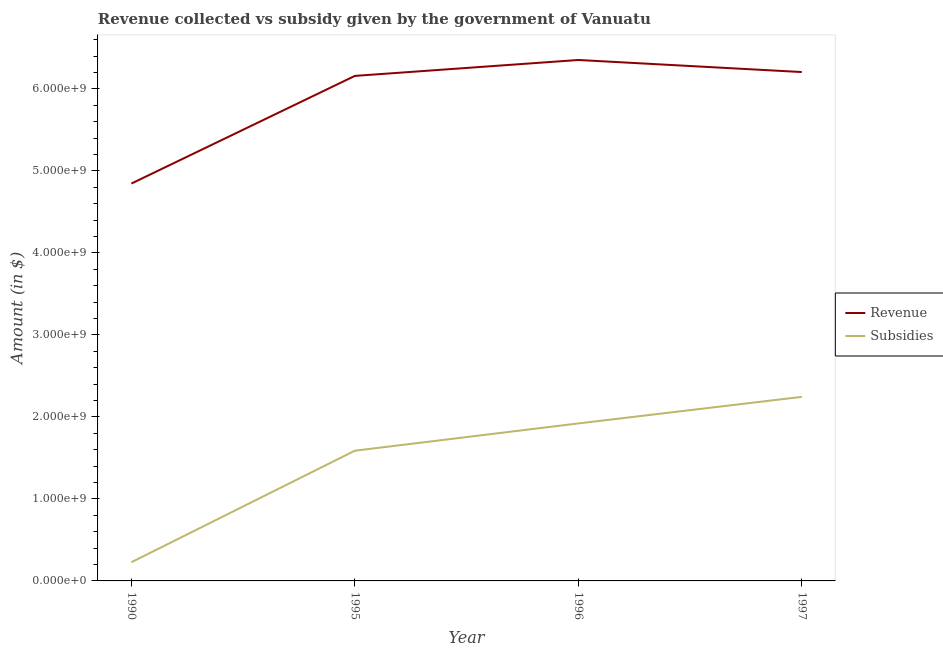Does the line corresponding to amount of subsidies given intersect with the line corresponding to amount of revenue collected?
Ensure brevity in your answer.  No. What is the amount of subsidies given in 1996?
Provide a succinct answer. 1.92e+09. Across all years, what is the maximum amount of subsidies given?
Make the answer very short. 2.24e+09. Across all years, what is the minimum amount of revenue collected?
Give a very brief answer. 4.85e+09. In which year was the amount of subsidies given minimum?
Provide a succinct answer. 1990. What is the total amount of subsidies given in the graph?
Your response must be concise. 5.98e+09. What is the difference between the amount of subsidies given in 1995 and that in 1996?
Offer a terse response. -3.33e+08. What is the difference between the amount of subsidies given in 1995 and the amount of revenue collected in 1990?
Provide a succinct answer. -3.26e+09. What is the average amount of subsidies given per year?
Give a very brief answer. 1.50e+09. In the year 1990, what is the difference between the amount of revenue collected and amount of subsidies given?
Give a very brief answer. 4.62e+09. What is the ratio of the amount of subsidies given in 1990 to that in 1997?
Keep it short and to the point. 0.1. What is the difference between the highest and the second highest amount of revenue collected?
Offer a terse response. 1.47e+08. What is the difference between the highest and the lowest amount of revenue collected?
Keep it short and to the point. 1.51e+09. In how many years, is the amount of revenue collected greater than the average amount of revenue collected taken over all years?
Your response must be concise. 3. Is the sum of the amount of subsidies given in 1990 and 1997 greater than the maximum amount of revenue collected across all years?
Offer a very short reply. No. Is the amount of subsidies given strictly greater than the amount of revenue collected over the years?
Your response must be concise. No. Is the amount of subsidies given strictly less than the amount of revenue collected over the years?
Ensure brevity in your answer.  Yes. How many lines are there?
Your answer should be compact. 2. What is the difference between two consecutive major ticks on the Y-axis?
Your answer should be compact. 1.00e+09. Does the graph contain any zero values?
Ensure brevity in your answer.  No. Does the graph contain grids?
Provide a succinct answer. No. What is the title of the graph?
Your response must be concise. Revenue collected vs subsidy given by the government of Vanuatu. Does "Fertility rate" appear as one of the legend labels in the graph?
Your response must be concise. No. What is the label or title of the Y-axis?
Keep it short and to the point. Amount (in $). What is the Amount (in $) in Revenue in 1990?
Offer a very short reply. 4.85e+09. What is the Amount (in $) in Subsidies in 1990?
Keep it short and to the point. 2.28e+08. What is the Amount (in $) in Revenue in 1995?
Ensure brevity in your answer.  6.16e+09. What is the Amount (in $) of Subsidies in 1995?
Your answer should be compact. 1.59e+09. What is the Amount (in $) of Revenue in 1996?
Offer a very short reply. 6.35e+09. What is the Amount (in $) of Subsidies in 1996?
Provide a short and direct response. 1.92e+09. What is the Amount (in $) in Revenue in 1997?
Ensure brevity in your answer.  6.20e+09. What is the Amount (in $) in Subsidies in 1997?
Your answer should be compact. 2.24e+09. Across all years, what is the maximum Amount (in $) in Revenue?
Provide a short and direct response. 6.35e+09. Across all years, what is the maximum Amount (in $) of Subsidies?
Your answer should be very brief. 2.24e+09. Across all years, what is the minimum Amount (in $) in Revenue?
Your response must be concise. 4.85e+09. Across all years, what is the minimum Amount (in $) in Subsidies?
Keep it short and to the point. 2.28e+08. What is the total Amount (in $) in Revenue in the graph?
Your answer should be compact. 2.36e+1. What is the total Amount (in $) in Subsidies in the graph?
Provide a succinct answer. 5.98e+09. What is the difference between the Amount (in $) in Revenue in 1990 and that in 1995?
Ensure brevity in your answer.  -1.31e+09. What is the difference between the Amount (in $) of Subsidies in 1990 and that in 1995?
Provide a short and direct response. -1.36e+09. What is the difference between the Amount (in $) of Revenue in 1990 and that in 1996?
Keep it short and to the point. -1.51e+09. What is the difference between the Amount (in $) in Subsidies in 1990 and that in 1996?
Provide a short and direct response. -1.69e+09. What is the difference between the Amount (in $) in Revenue in 1990 and that in 1997?
Offer a terse response. -1.36e+09. What is the difference between the Amount (in $) of Subsidies in 1990 and that in 1997?
Keep it short and to the point. -2.02e+09. What is the difference between the Amount (in $) in Revenue in 1995 and that in 1996?
Offer a terse response. -1.94e+08. What is the difference between the Amount (in $) in Subsidies in 1995 and that in 1996?
Offer a terse response. -3.33e+08. What is the difference between the Amount (in $) of Revenue in 1995 and that in 1997?
Make the answer very short. -4.70e+07. What is the difference between the Amount (in $) of Subsidies in 1995 and that in 1997?
Your answer should be very brief. -6.57e+08. What is the difference between the Amount (in $) in Revenue in 1996 and that in 1997?
Offer a very short reply. 1.47e+08. What is the difference between the Amount (in $) in Subsidies in 1996 and that in 1997?
Your response must be concise. -3.24e+08. What is the difference between the Amount (in $) in Revenue in 1990 and the Amount (in $) in Subsidies in 1995?
Make the answer very short. 3.26e+09. What is the difference between the Amount (in $) in Revenue in 1990 and the Amount (in $) in Subsidies in 1996?
Offer a terse response. 2.92e+09. What is the difference between the Amount (in $) in Revenue in 1990 and the Amount (in $) in Subsidies in 1997?
Provide a short and direct response. 2.60e+09. What is the difference between the Amount (in $) of Revenue in 1995 and the Amount (in $) of Subsidies in 1996?
Provide a succinct answer. 4.24e+09. What is the difference between the Amount (in $) in Revenue in 1995 and the Amount (in $) in Subsidies in 1997?
Offer a terse response. 3.91e+09. What is the difference between the Amount (in $) in Revenue in 1996 and the Amount (in $) in Subsidies in 1997?
Give a very brief answer. 4.11e+09. What is the average Amount (in $) of Revenue per year?
Offer a very short reply. 5.89e+09. What is the average Amount (in $) in Subsidies per year?
Ensure brevity in your answer.  1.50e+09. In the year 1990, what is the difference between the Amount (in $) of Revenue and Amount (in $) of Subsidies?
Provide a short and direct response. 4.62e+09. In the year 1995, what is the difference between the Amount (in $) in Revenue and Amount (in $) in Subsidies?
Keep it short and to the point. 4.57e+09. In the year 1996, what is the difference between the Amount (in $) of Revenue and Amount (in $) of Subsidies?
Offer a very short reply. 4.43e+09. In the year 1997, what is the difference between the Amount (in $) in Revenue and Amount (in $) in Subsidies?
Offer a very short reply. 3.96e+09. What is the ratio of the Amount (in $) of Revenue in 1990 to that in 1995?
Your answer should be very brief. 0.79. What is the ratio of the Amount (in $) in Subsidies in 1990 to that in 1995?
Keep it short and to the point. 0.14. What is the ratio of the Amount (in $) in Revenue in 1990 to that in 1996?
Provide a short and direct response. 0.76. What is the ratio of the Amount (in $) in Subsidies in 1990 to that in 1996?
Ensure brevity in your answer.  0.12. What is the ratio of the Amount (in $) in Revenue in 1990 to that in 1997?
Give a very brief answer. 0.78. What is the ratio of the Amount (in $) of Subsidies in 1990 to that in 1997?
Ensure brevity in your answer.  0.1. What is the ratio of the Amount (in $) in Revenue in 1995 to that in 1996?
Keep it short and to the point. 0.97. What is the ratio of the Amount (in $) of Subsidies in 1995 to that in 1996?
Offer a very short reply. 0.83. What is the ratio of the Amount (in $) of Revenue in 1995 to that in 1997?
Offer a terse response. 0.99. What is the ratio of the Amount (in $) in Subsidies in 1995 to that in 1997?
Offer a very short reply. 0.71. What is the ratio of the Amount (in $) of Revenue in 1996 to that in 1997?
Your response must be concise. 1.02. What is the ratio of the Amount (in $) in Subsidies in 1996 to that in 1997?
Your answer should be compact. 0.86. What is the difference between the highest and the second highest Amount (in $) of Revenue?
Give a very brief answer. 1.47e+08. What is the difference between the highest and the second highest Amount (in $) in Subsidies?
Provide a short and direct response. 3.24e+08. What is the difference between the highest and the lowest Amount (in $) in Revenue?
Provide a short and direct response. 1.51e+09. What is the difference between the highest and the lowest Amount (in $) of Subsidies?
Keep it short and to the point. 2.02e+09. 